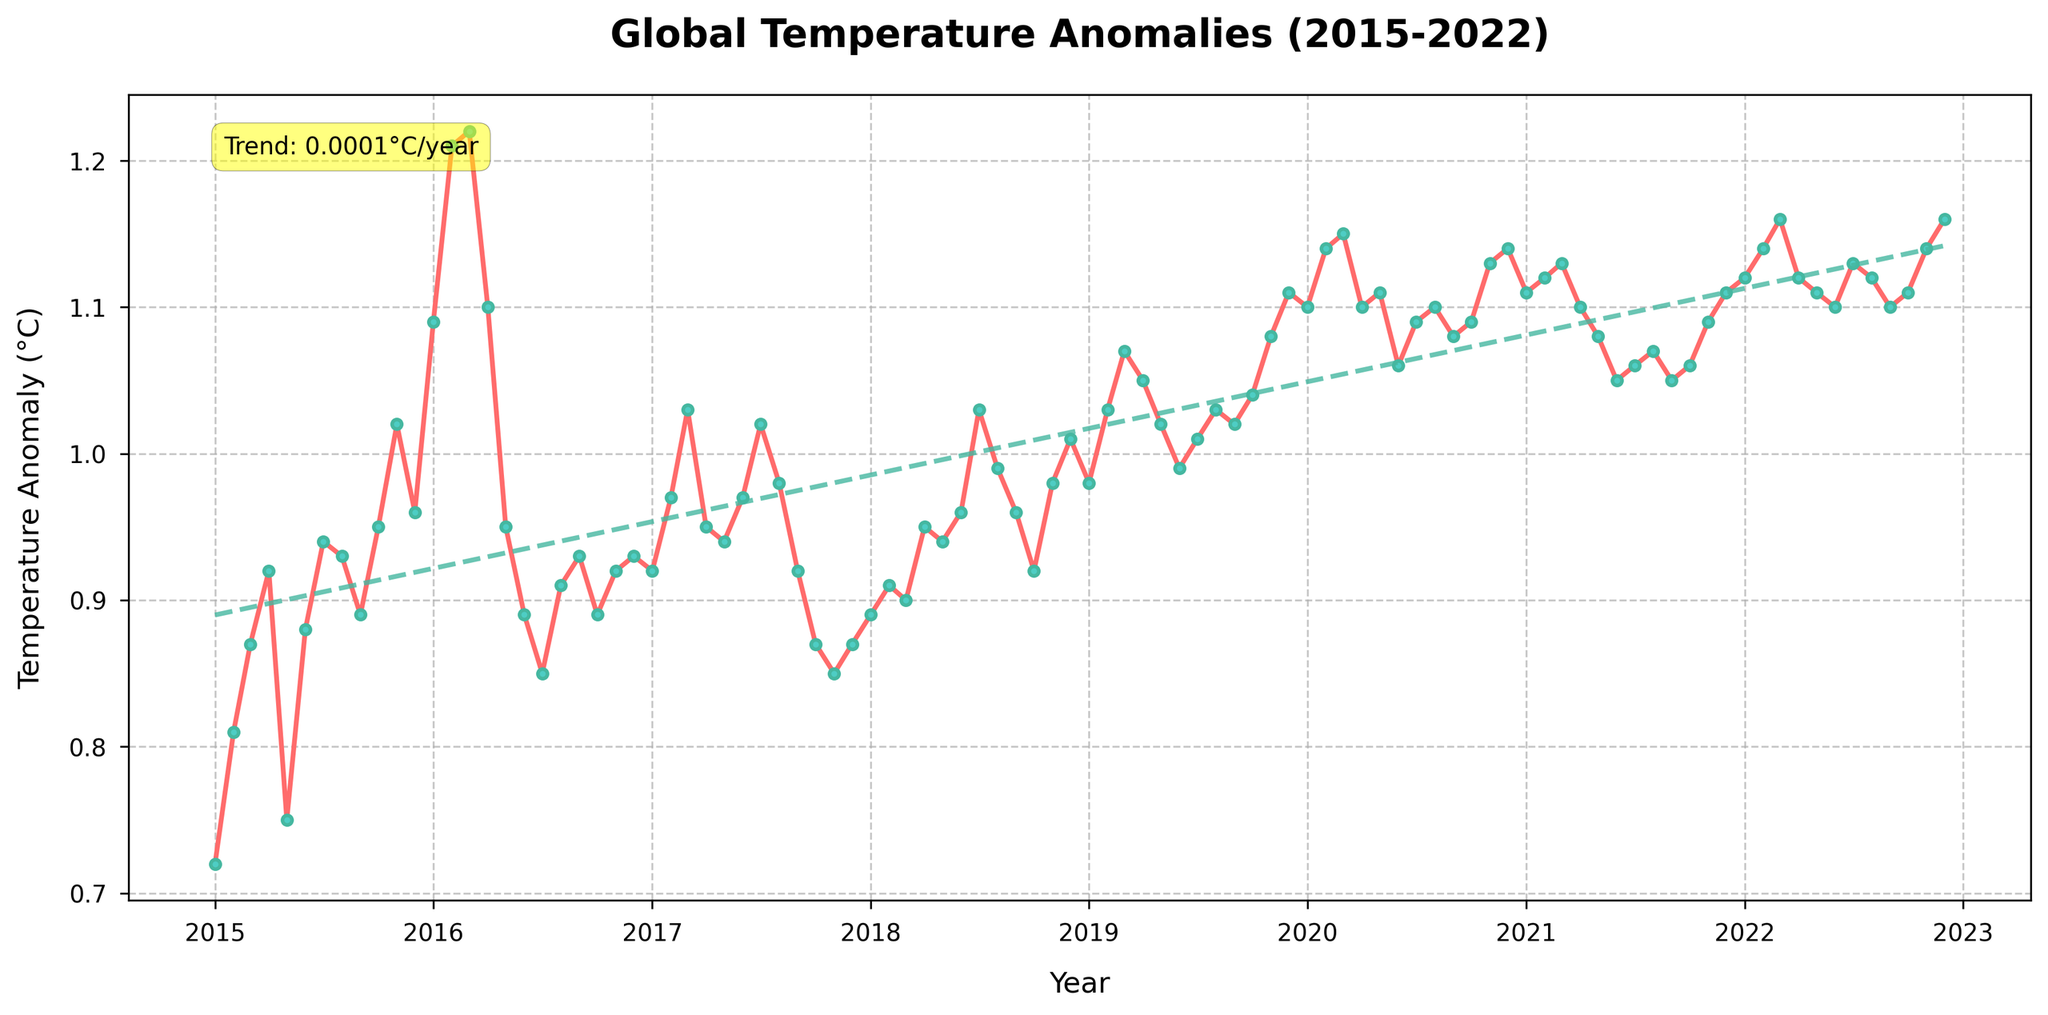Which year has the highest average temperature anomaly? To find the year with the highest average temperature anomaly, look at the trend line and the yearly temperature anomaly values. Year 2022 shows the highest average with consistent values around 1.12°C.
Answer: 2022 What is the overall trend in temperature anomalies from 2015 to 2022? Check the trend line added to the plot. The rising slope indicates an upward trend in temperature anomalies over the years. The trend line slopes upward from 2015 to 2022.
Answer: Increasing Which month in 2016 had the highest temperature anomaly? Look at the points plotted for the year 2016 and compare the values. February 2016 has the highest anomaly value of 1.21°C.
Answer: February 2016 How does the temperature anomaly in July 2020 compare to July 2015? Compare the temperature anomaly values for July 2020 and July 2015. The temperature anomaly was 1.09°C in July 2020 and 0.94°C in July 2015.
Answer: Higher in July 2020 What is the color and style of the trend line used in the plot? Observe the visual properties of the trend line, which is displayed as a dashed line with a color that appears green (coded as #45B7A0).
Answer: Green dashed line What is the temperature anomaly for December 2020? Locate the data point for December 2020 in the plot. It shows a temperature anomaly of about 1.14°C.
Answer: 1.14°C Does the temperature anomaly show significant seasonal variation? Review the monthly data points and the overall trend. There are slight fluctuations each year, but the overall rising trend is more significant.
Answer: Yes What is the temperature anomaly in the month with the lowest anomaly in the dataset? Find the minimum value in the plot, which occurs in January 2015 with a temperature anomaly of around 0.72°C.
Answer: 0.72°C 